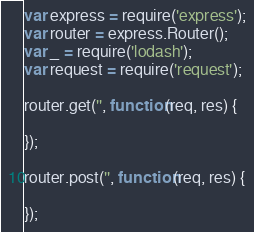Convert code to text. <code><loc_0><loc_0><loc_500><loc_500><_JavaScript_>var express = require('express');
var router = express.Router();
var _ = require('lodash');
var request = require('request');

router.get('', function(req, res) {

});

router.post('', function(req, res) {

});

</code> 